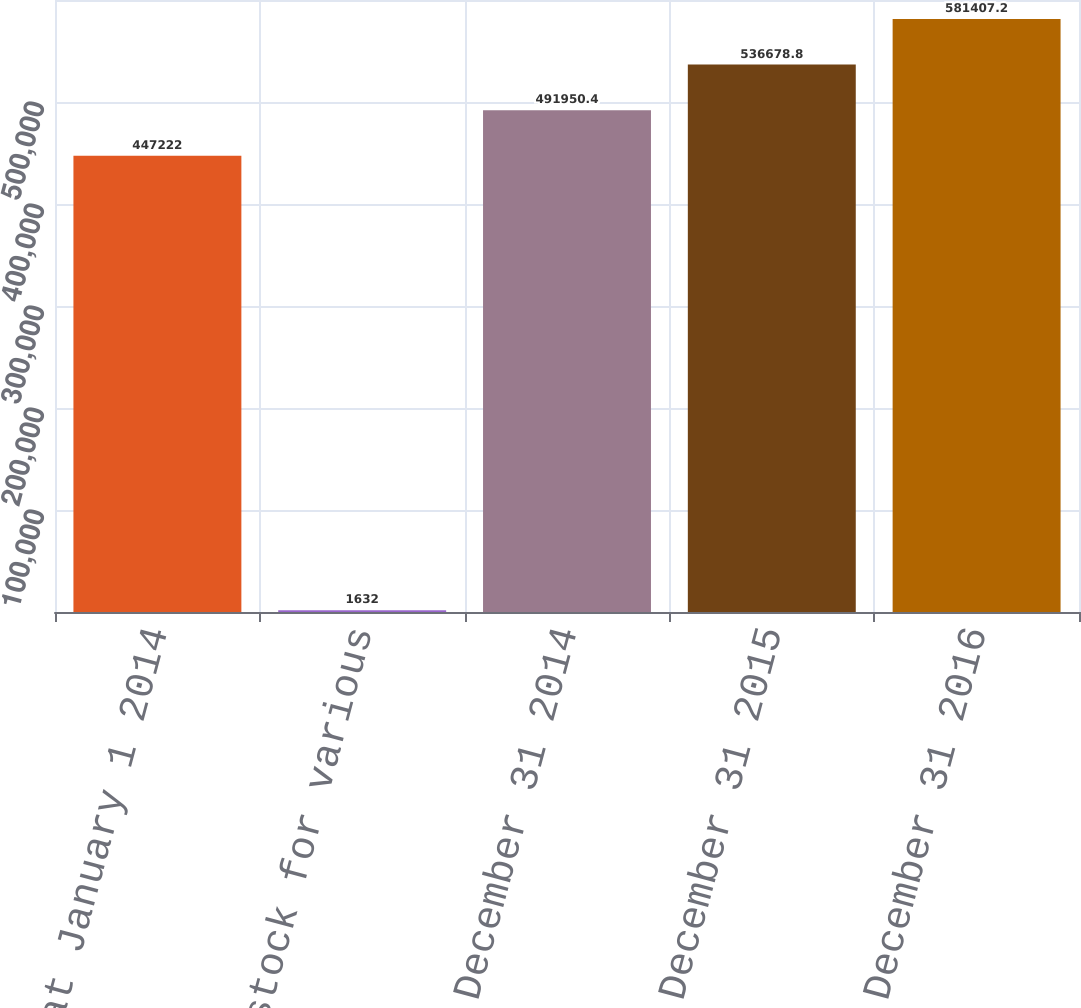<chart> <loc_0><loc_0><loc_500><loc_500><bar_chart><fcel>Balance at January 1 2014<fcel>Issuance of stock for various<fcel>Balance at December 31 2014<fcel>Balance at December 31 2015<fcel>Balance at December 31 2016<nl><fcel>447222<fcel>1632<fcel>491950<fcel>536679<fcel>581407<nl></chart> 